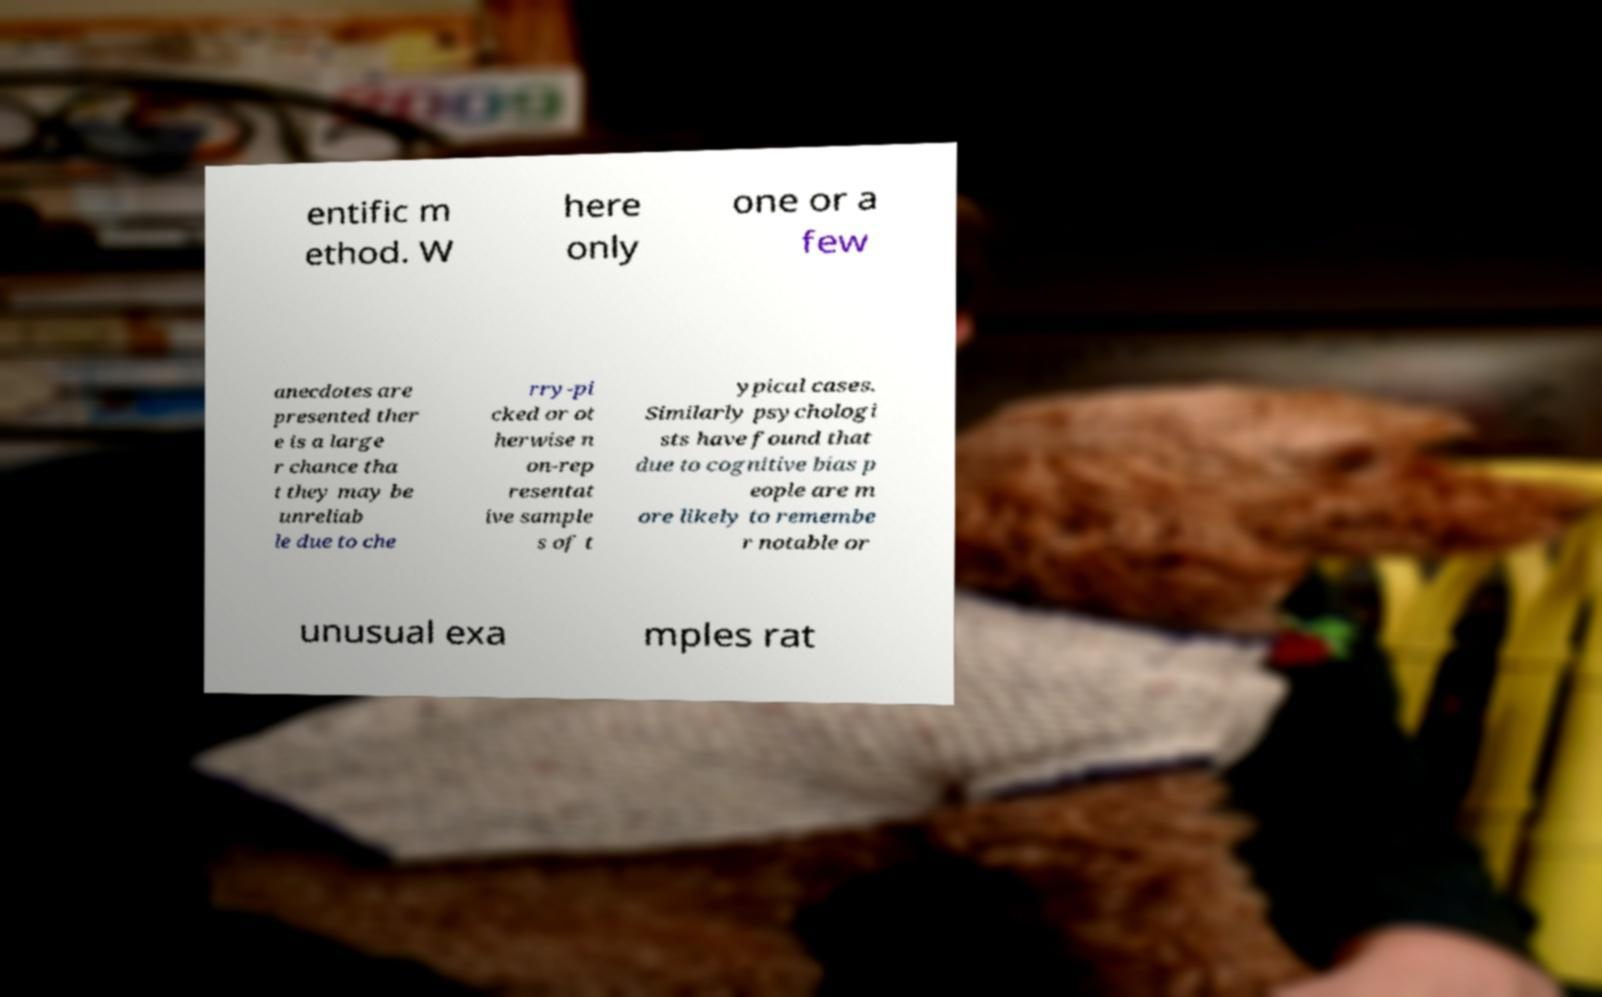Please identify and transcribe the text found in this image. entific m ethod. W here only one or a few anecdotes are presented ther e is a large r chance tha t they may be unreliab le due to che rry-pi cked or ot herwise n on-rep resentat ive sample s of t ypical cases. Similarly psychologi sts have found that due to cognitive bias p eople are m ore likely to remembe r notable or unusual exa mples rat 